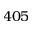Convert formula to latex. <formula><loc_0><loc_0><loc_500><loc_500>4 0 5</formula> 